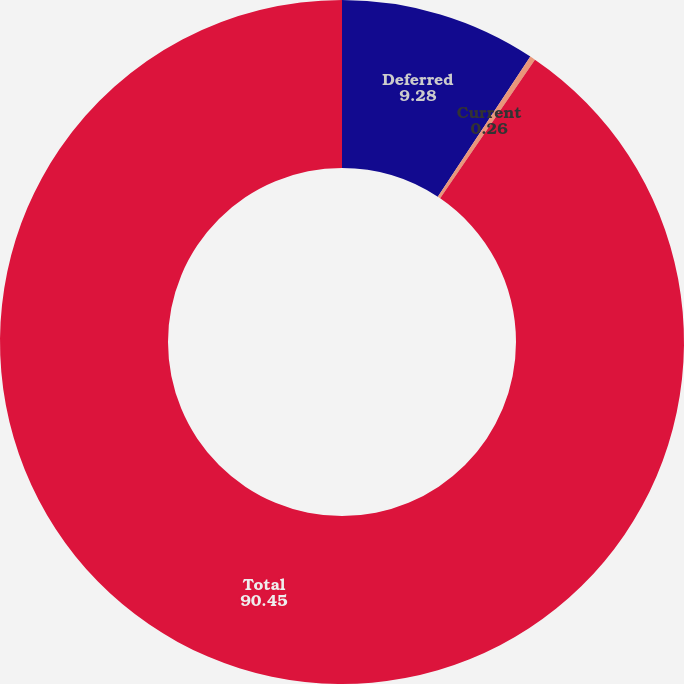Convert chart. <chart><loc_0><loc_0><loc_500><loc_500><pie_chart><fcel>Deferred<fcel>Current<fcel>Total<nl><fcel>9.28%<fcel>0.26%<fcel>90.45%<nl></chart> 